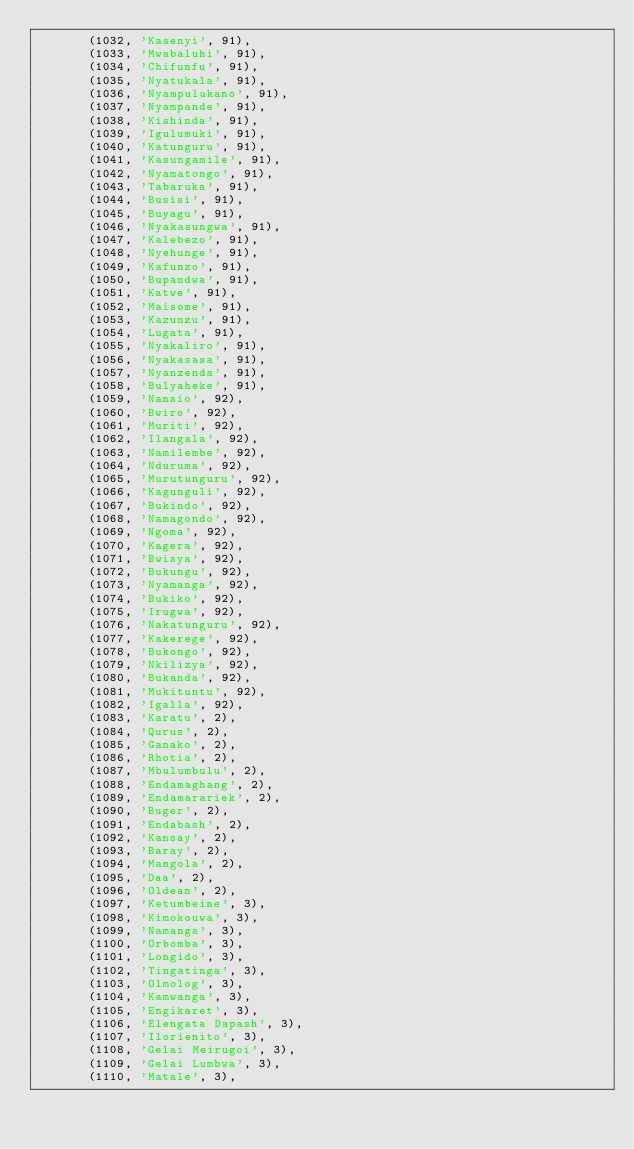<code> <loc_0><loc_0><loc_500><loc_500><_SQL_>       (1032, 'Kasenyi', 91),
       (1033, 'Mwabaluhi', 91),
       (1034, 'Chifunfu', 91),
       (1035, 'Nyatukala', 91),
       (1036, 'Nyampulukano', 91),
       (1037, 'Nyampande', 91),
       (1038, 'Kishinda', 91),
       (1039, 'Igulumuki', 91),
       (1040, 'Katunguru', 91),
       (1041, 'Kasungamile', 91),
       (1042, 'Nyamatongo', 91),
       (1043, 'Tabaruka', 91),
       (1044, 'Busisi', 91),
       (1045, 'Buyagu', 91),
       (1046, 'Nyakasungwa', 91),
       (1047, 'Kalebezo', 91),
       (1048, 'Nyehunge', 91),
       (1049, 'Kafunzo', 91),
       (1050, 'Bupandwa', 91),
       (1051, 'Katwe', 91),
       (1052, 'Maisome', 91),
       (1053, 'Kazunzu', 91),
       (1054, 'Lugata', 91),
       (1055, 'Nyakaliro', 91),
       (1056, 'Nyakasasa', 91),
       (1057, 'Nyanzenda', 91),
       (1058, 'Bulyaheke', 91),
       (1059, 'Nansio', 92),
       (1060, 'Bwiro', 92),
       (1061, 'Muriti', 92),
       (1062, 'Ilangala', 92),
       (1063, 'Namilembe', 92),
       (1064, 'Nduruma', 92),
       (1065, 'Murutunguru', 92),
       (1066, 'Kagunguli', 92),
       (1067, 'Bukindo', 92),
       (1068, 'Namagondo', 92),
       (1069, 'Ngoma', 92),
       (1070, 'Kagera', 92),
       (1071, 'Bwisya', 92),
       (1072, 'Bukungu', 92),
       (1073, 'Nyamanga', 92),
       (1074, 'Bukiko', 92),
       (1075, 'Irugwa', 92),
       (1076, 'Nakatunguru', 92),
       (1077, 'Kakerege', 92),
       (1078, 'Bukongo', 92),
       (1079, 'Nkilizya', 92),
       (1080, 'Bukanda', 92),
       (1081, 'Mukituntu', 92),
       (1082, 'Igalla', 92),
       (1083, 'Karatu', 2),
       (1084, 'Qurus', 2),
       (1085, 'Ganako', 2),
       (1086, 'Rhotia', 2),
       (1087, 'Mbulumbulu', 2),
       (1088, 'Endamaghang', 2),
       (1089, 'Endamarariek', 2),
       (1090, 'Buger', 2),
       (1091, 'Endabash', 2),
       (1092, 'Kansay', 2),
       (1093, 'Baray', 2),
       (1094, 'Mangola', 2),
       (1095, 'Daa', 2),
       (1096, 'Oldean', 2),
       (1097, 'Ketumbeine', 3),
       (1098, 'Kimokouwa', 3),
       (1099, 'Namanga', 3),
       (1100, 'Orbomba', 3),
       (1101, 'Longido', 3),
       (1102, 'Tingatinga', 3),
       (1103, 'Olmolog', 3),
       (1104, 'Kamwanga', 3),
       (1105, 'Engikaret', 3),
       (1106, 'Elengata Dapash', 3),
       (1107, 'Ilorienito', 3),
       (1108, 'Gelai Meirugoi', 3),
       (1109, 'Gelai Lumbwa', 3),
       (1110, 'Matale', 3),</code> 